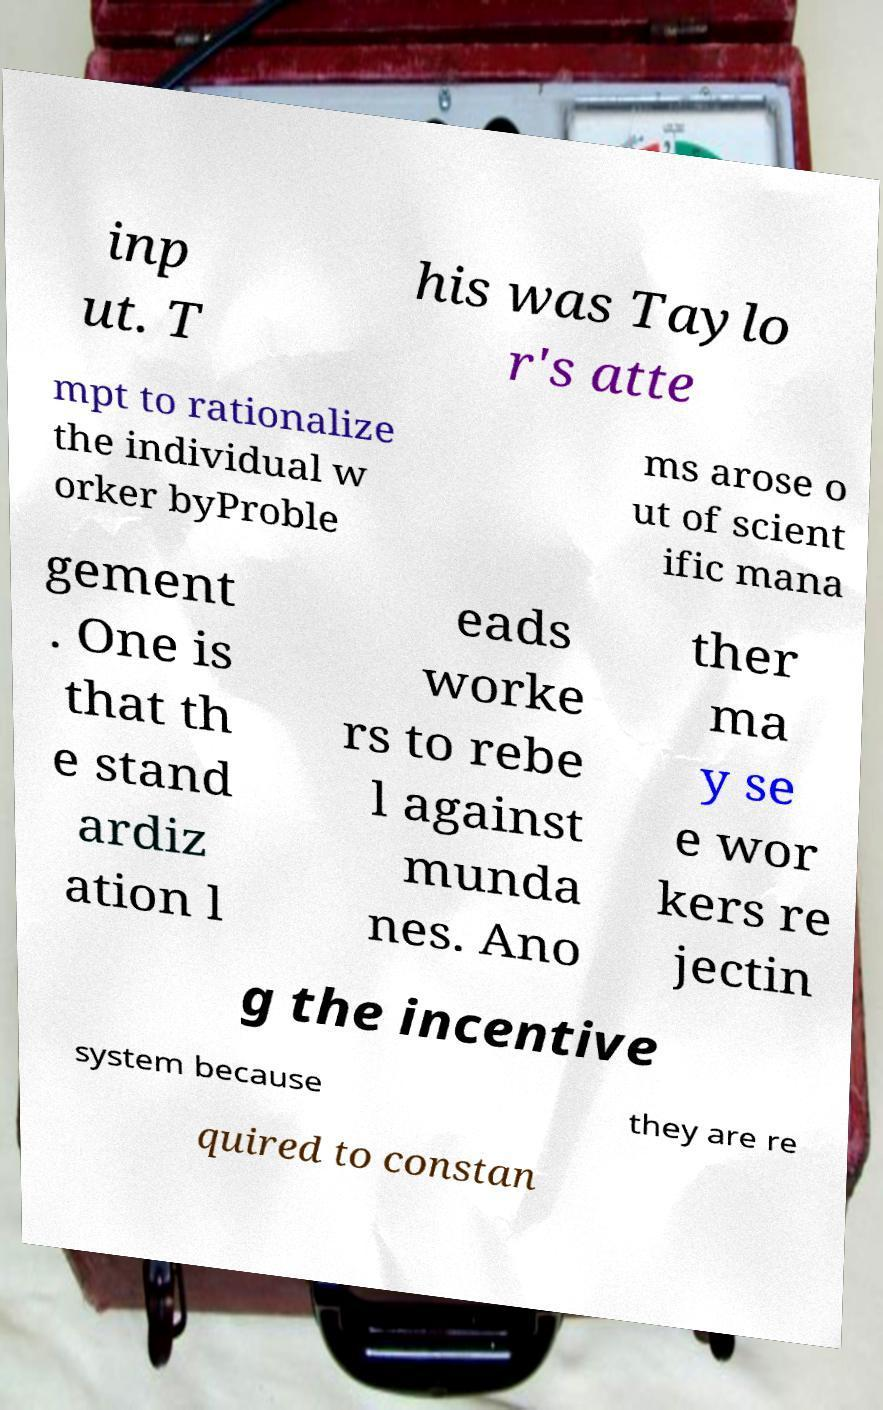There's text embedded in this image that I need extracted. Can you transcribe it verbatim? inp ut. T his was Taylo r's atte mpt to rationalize the individual w orker byProble ms arose o ut of scient ific mana gement . One is that th e stand ardiz ation l eads worke rs to rebe l against munda nes. Ano ther ma y se e wor kers re jectin g the incentive system because they are re quired to constan 